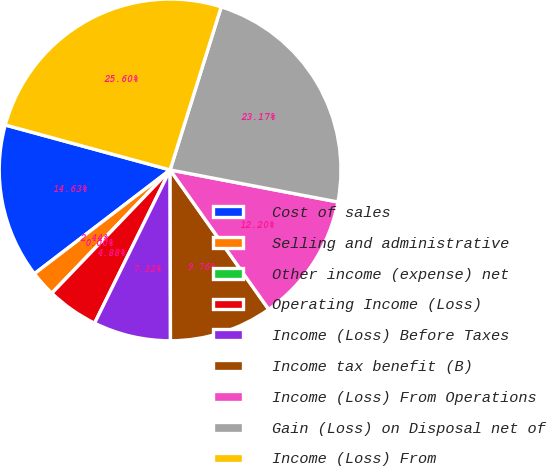<chart> <loc_0><loc_0><loc_500><loc_500><pie_chart><fcel>Cost of sales<fcel>Selling and administrative<fcel>Other income (expense) net<fcel>Operating Income (Loss)<fcel>Income (Loss) Before Taxes<fcel>Income tax benefit (B)<fcel>Income (Loss) From Operations<fcel>Gain (Loss) on Disposal net of<fcel>Income (Loss) From<nl><fcel>14.63%<fcel>2.44%<fcel>0.0%<fcel>4.88%<fcel>7.32%<fcel>9.76%<fcel>12.2%<fcel>23.17%<fcel>25.6%<nl></chart> 